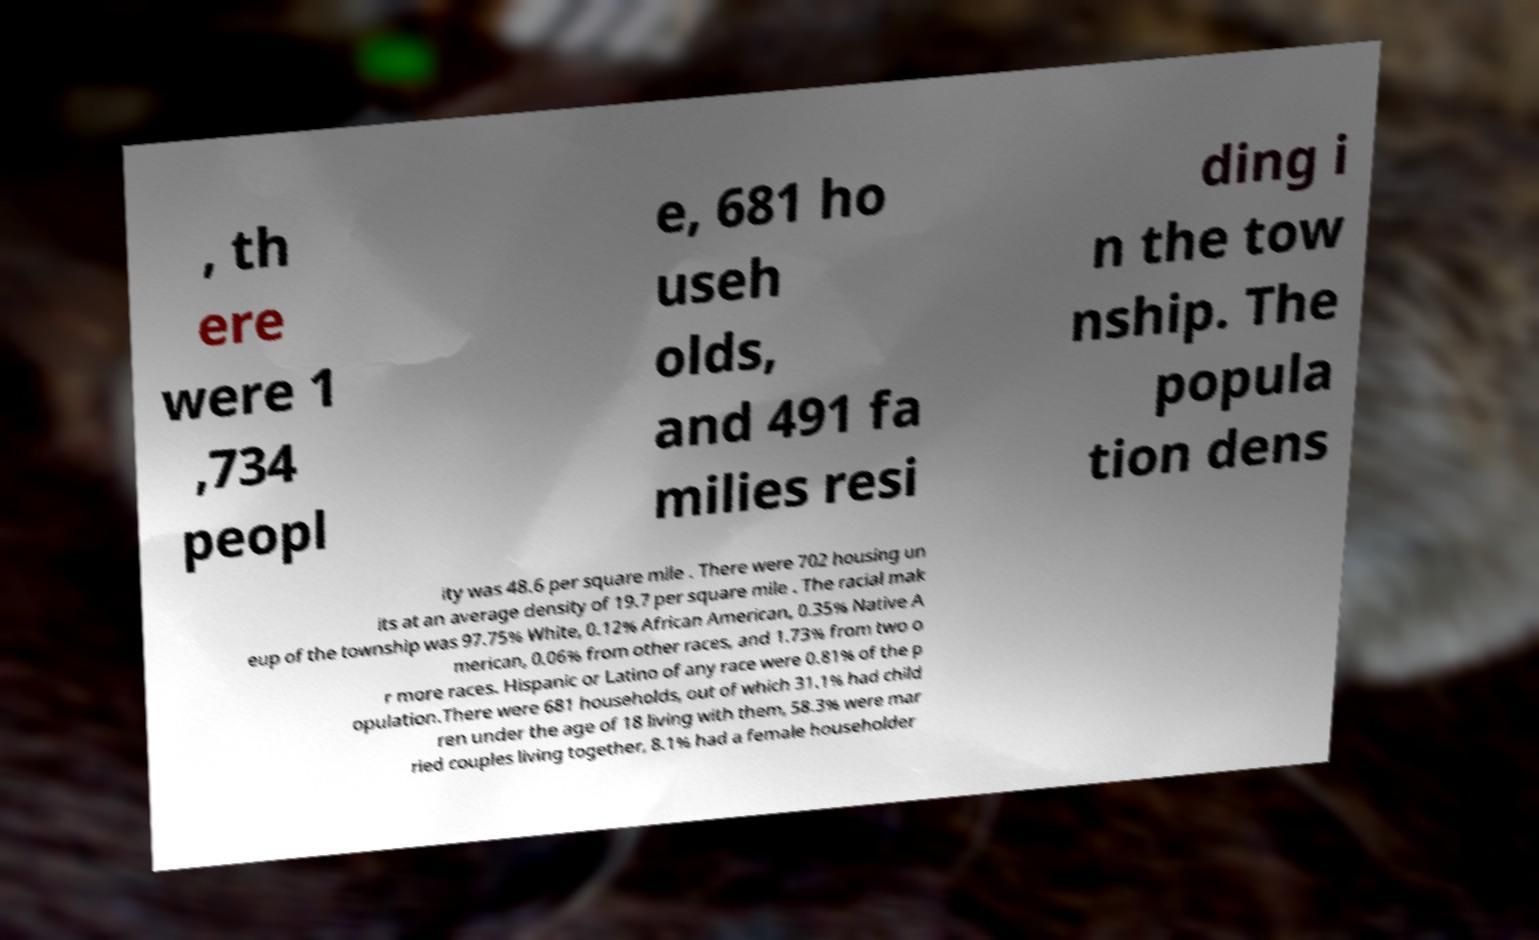Please identify and transcribe the text found in this image. , th ere were 1 ,734 peopl e, 681 ho useh olds, and 491 fa milies resi ding i n the tow nship. The popula tion dens ity was 48.6 per square mile . There were 702 housing un its at an average density of 19.7 per square mile . The racial mak eup of the township was 97.75% White, 0.12% African American, 0.35% Native A merican, 0.06% from other races, and 1.73% from two o r more races. Hispanic or Latino of any race were 0.81% of the p opulation.There were 681 households, out of which 31.1% had child ren under the age of 18 living with them, 58.3% were mar ried couples living together, 8.1% had a female householder 